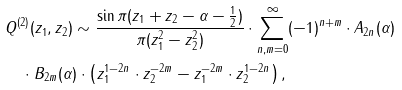<formula> <loc_0><loc_0><loc_500><loc_500>& Q ^ { ( 2 ) } ( z _ { 1 } , z _ { 2 } ) \sim \frac { \sin \pi ( z _ { 1 } + z _ { 2 } - \alpha - \frac { 1 } { 2 } ) } { \pi ( z _ { 1 } ^ { 2 } - z ^ { 2 } _ { 2 } ) } \cdot \sum ^ { \infty } _ { n , m = 0 } ( - 1 ) ^ { n + m } \cdot A _ { 2 n } ( \alpha ) \\ & \quad \cdot B _ { 2 m } ( \alpha ) \cdot \left ( z _ { 1 } ^ { 1 - 2 n } \cdot z _ { 2 } ^ { - 2 m } - z _ { 1 } ^ { - 2 m } \cdot z _ { 2 } ^ { 1 - 2 n } \right ) ,</formula> 